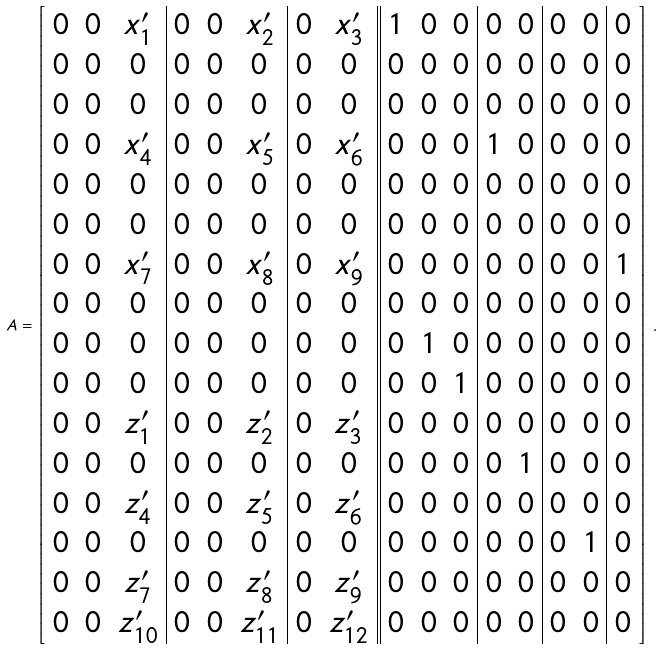<formula> <loc_0><loc_0><loc_500><loc_500>A = \left [ \begin{array} { c c c | c c c | c c | | c c c | c c | c c | c } 0 & 0 & x ^ { \prime } _ { 1 } & 0 & 0 & x ^ { \prime } _ { 2 } & 0 & x ^ { \prime } _ { 3 } & 1 & 0 & 0 & 0 & 0 & 0 & 0 & 0 \\ 0 & 0 & 0 & 0 & 0 & 0 & 0 & 0 & 0 & 0 & 0 & 0 & 0 & 0 & 0 & 0 \\ 0 & 0 & 0 & 0 & 0 & 0 & 0 & 0 & 0 & 0 & 0 & 0 & 0 & 0 & 0 & 0 \\ 0 & 0 & x ^ { \prime } _ { 4 } & 0 & 0 & x ^ { \prime } _ { 5 } & 0 & x ^ { \prime } _ { 6 } & 0 & 0 & 0 & 1 & 0 & 0 & 0 & 0 \\ 0 & 0 & 0 & 0 & 0 & 0 & 0 & 0 & 0 & 0 & 0 & 0 & 0 & 0 & 0 & 0 \\ 0 & 0 & 0 & 0 & 0 & 0 & 0 & 0 & 0 & 0 & 0 & 0 & 0 & 0 & 0 & 0 \\ 0 & 0 & x ^ { \prime } _ { 7 } & 0 & 0 & x ^ { \prime } _ { 8 } & 0 & x ^ { \prime } _ { 9 } & 0 & 0 & 0 & 0 & 0 & 0 & 0 & 1 \\ 0 & 0 & 0 & 0 & 0 & 0 & 0 & 0 & 0 & 0 & 0 & 0 & 0 & 0 & 0 & 0 \\ 0 & 0 & 0 & 0 & 0 & 0 & 0 & 0 & 0 & 1 & 0 & 0 & 0 & 0 & 0 & 0 \\ 0 & 0 & 0 & 0 & 0 & 0 & 0 & 0 & 0 & 0 & 1 & 0 & 0 & 0 & 0 & 0 \\ 0 & 0 & z ^ { \prime } _ { 1 } & 0 & 0 & z ^ { \prime } _ { 2 } & 0 & z ^ { \prime } _ { 3 } & 0 & 0 & 0 & 0 & 0 & 0 & 0 & 0 \\ 0 & 0 & 0 & 0 & 0 & 0 & 0 & 0 & 0 & 0 & 0 & 0 & 1 & 0 & 0 & 0 \\ 0 & 0 & z ^ { \prime } _ { 4 } & 0 & 0 & z ^ { \prime } _ { 5 } & 0 & z ^ { \prime } _ { 6 } & 0 & 0 & 0 & 0 & 0 & 0 & 0 & 0 \\ 0 & 0 & 0 & 0 & 0 & 0 & 0 & 0 & 0 & 0 & 0 & 0 & 0 & 0 & 1 & 0 \\ 0 & 0 & z ^ { \prime } _ { 7 } & 0 & 0 & z ^ { \prime } _ { 8 } & 0 & z ^ { \prime } _ { 9 } & 0 & 0 & 0 & 0 & 0 & 0 & 0 & 0 \\ 0 & 0 & z ^ { \prime } _ { 1 0 } & 0 & 0 & z ^ { \prime } _ { 1 1 } & 0 & z ^ { \prime } _ { 1 2 } & 0 & 0 & 0 & 0 & 0 & 0 & 0 & 0 \end{array} \right ] \, .</formula> 